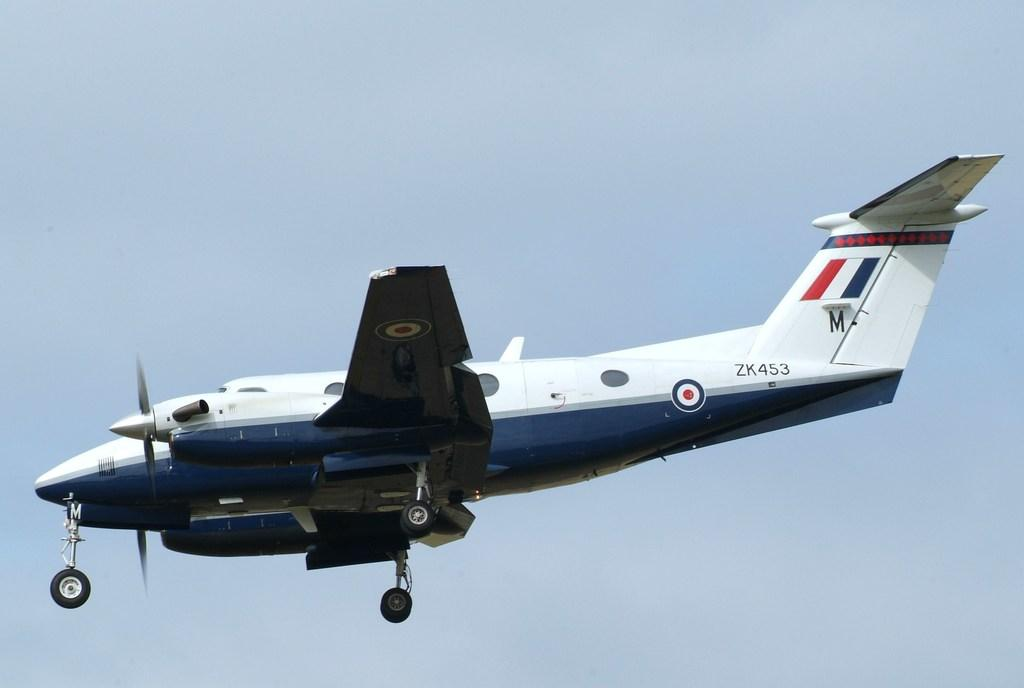<image>
Describe the image concisely. A white and blue airplane has ZK453 near its tail. 